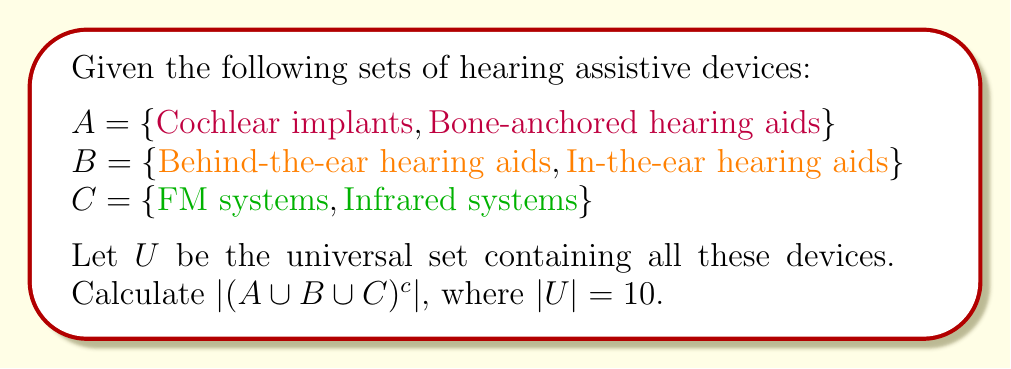Show me your answer to this math problem. To solve this problem, we'll follow these steps:

1) First, let's understand what the question is asking:
   - We need to find the cardinality (number of elements) of the complement of $A \cup B \cup C$.
   - The complement is denoted by the superscript $c$.

2) Let's count the elements in each set:
   $|A| = 2$
   $|B| = 2$
   $|C| = 2$

3) Now, $A \cup B \cup C$ contains all the elements from sets $A$, $B$, and $C$. Since these sets are disjoint (no common elements), we can simply add their cardinalities:

   $|A \cup B \cup C| = |A| + |B| + |C| = 2 + 2 + 2 = 6$

4) The complement of $A \cup B \cup C$ will contain all elements in $U$ that are not in $A \cup B \cup C$. We can calculate this using the formula:

   $|(A \cup B \cup C)^c| = |U| - |A \cup B \cup C|$

5) We're given that $|U| = 10$, so:

   $|(A \cup B \cup C)^c| = 10 - 6 = 4$

Therefore, there are 4 elements in the universal set $U$ that are not in $A$, $B$, or $C$. These could represent other types of hearing assistive devices not mentioned in the given sets.
Answer: $|(A \cup B \cup C)^c| = 4$ 